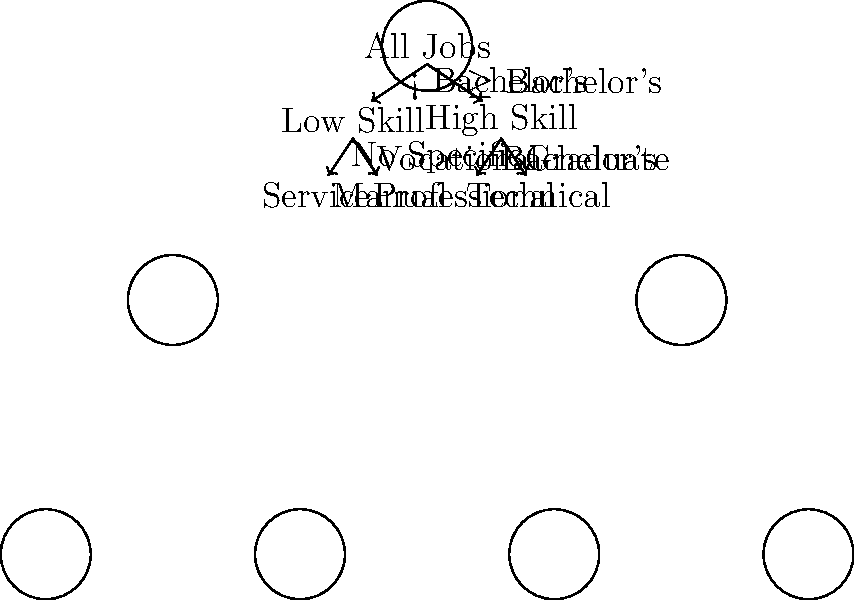Based on the decision tree diagram, which education level is typically required for jobs classified in the "Technical" sector? To determine the education level typically required for jobs in the "Technical" sector, let's follow the decision tree:

1. We start at the root node "All Jobs".
2. The first split is based on whether a job requires a Bachelor's degree or higher.
3. The "Technical" sector is on the right side of this split, indicating it requires $\geq$ Bachelor's degree.
4. Moving down to the "High Skill" node, we see another split.
5. The "Technical" sector is on the right side of this split, corresponding to "Graduate" level education.

Therefore, according to this decision tree, jobs classified in the "Technical" sector typically require a graduate-level education.

This classification aligns with the real-world observation that many technical jobs, especially in advanced fields, often require specialized knowledge and skills obtained through graduate-level studies. However, it's important to note that this is a simplified model, and actual job requirements can vary depending on the specific role and industry.
Answer: Graduate 